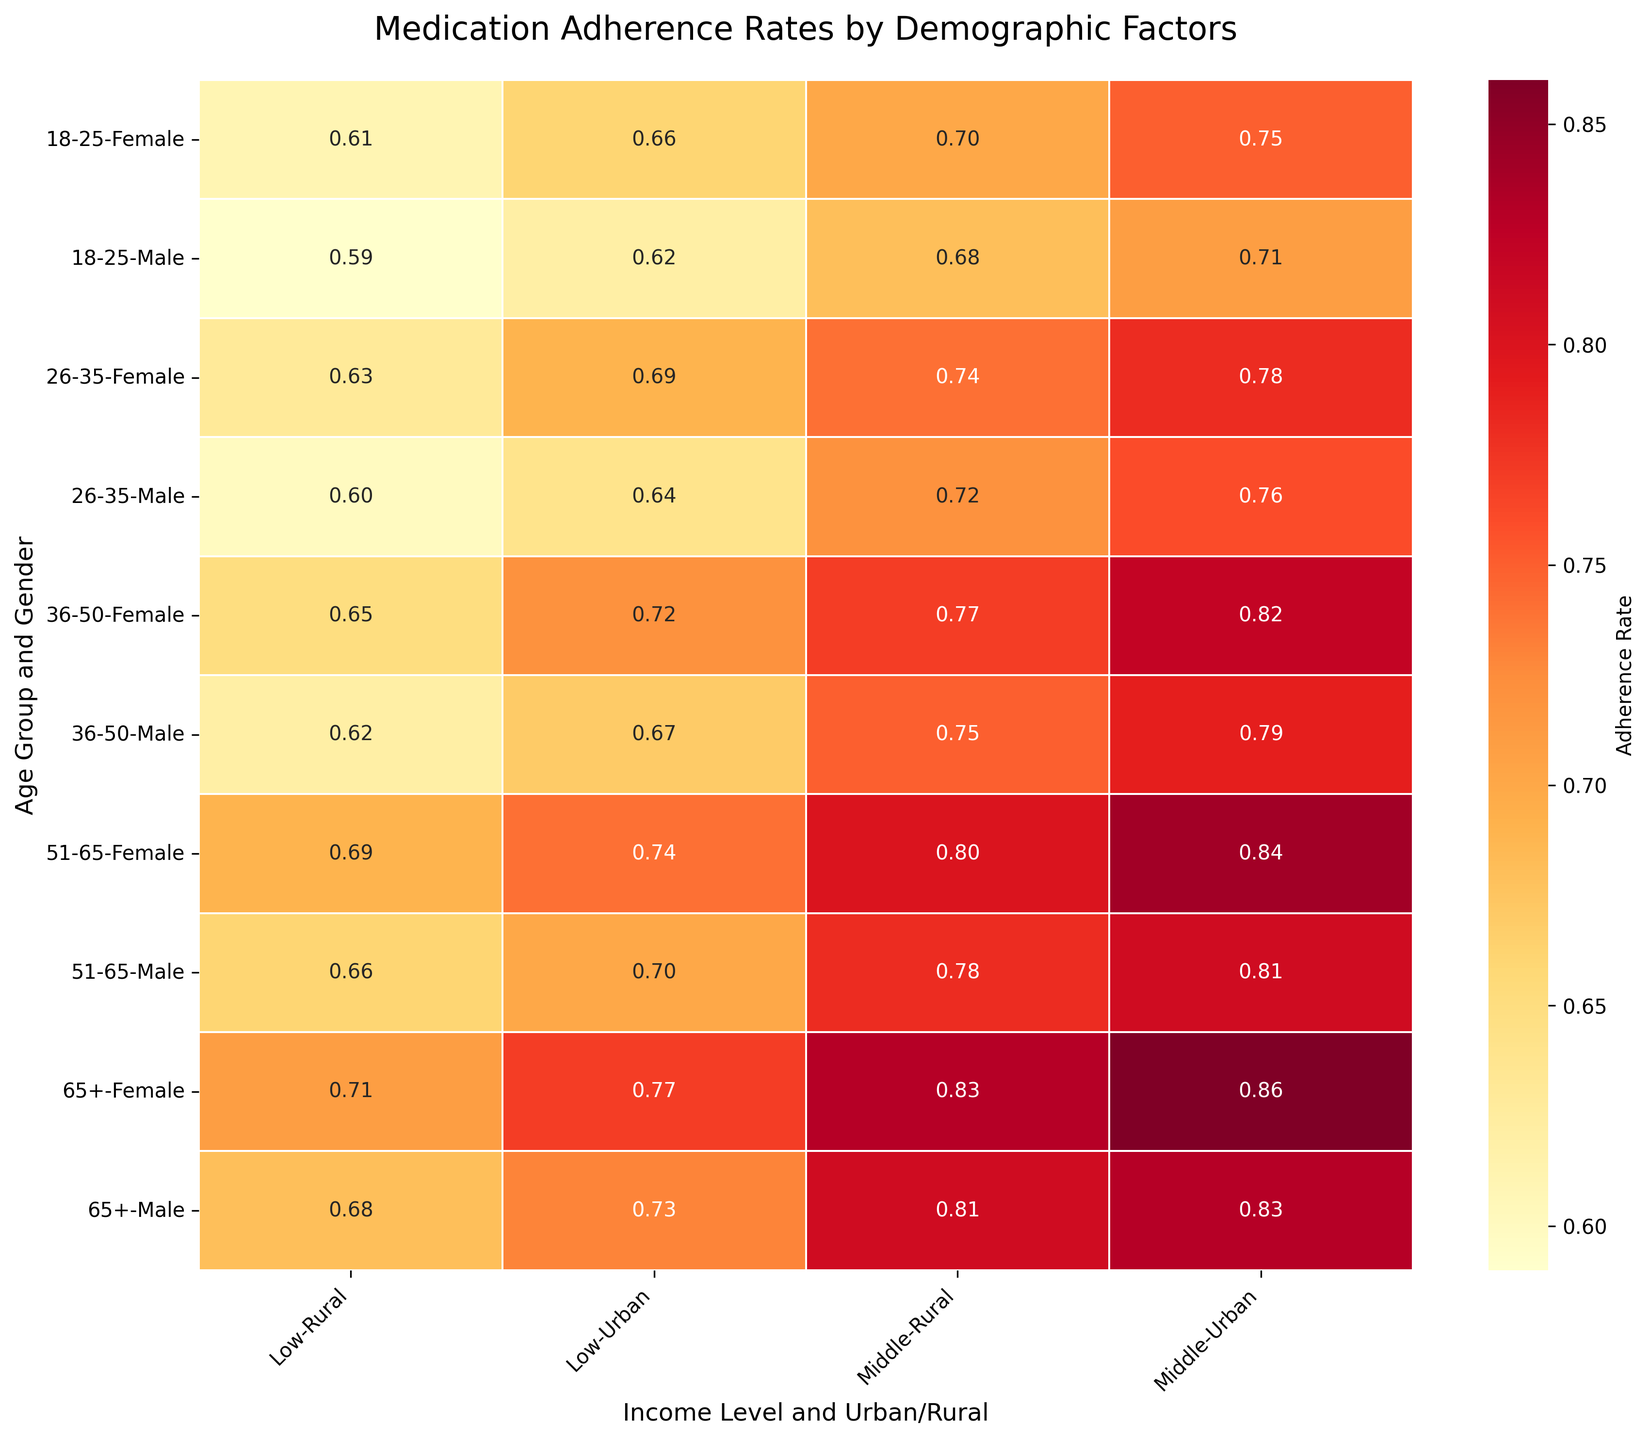What is the title of the heatmap? The title of the heatmap is displayed at the top of the figure.
Answer: Medication Adherence Rates by Demographic Factors Which demographic group has the highest adherence rate? The highest adherence rate is indicated by the darkest shade on the heatmap. This corresponds to the "65+, Middle Income, Female, Urban" group.
Answer: 0.86 How does the adherence rate for females compare between urban and rural settings for the age group 51-65 and middle income? By examining the heatmap, we can see the adherence rates for females aged 51-65 in the middle-income bracket are higher in urban settings compared to rural settings.
Answer: Urban: 0.84, Rural: 0.80 Is there a general trend in adherence rates between income levels for the age group 36-50? By comparing the colors for low and middle-income levels for each gender in this age group, we can observe that adherence rates are generally higher for middle-income individuals.
Answer: Middle > Low What is the difference in adherence rates between males and females in the age group 18-25 with middle income in rural settings? Checking the values directly from the heatmap shows that the adherence rate for females is higher by 0.02.
Answer: 0.02 What's the average adherence rate for the group 26-35, low income, urban? The adherence rates for males and females are provided separately. We need to average these two values (0.64 + 0.69)/2 = 0.665.
Answer: 0.665 Which age group shows the least variation in adherence rates across different settings? By visually inspecting the colors and variation in the heatmap, the age group that shows the least variation is 51-65.
Answer: 51-65 For the age group 36-50, how does the adherence rate for urban middle-income males compare to rural low-income females? By looking at the respective values in the heatmap, we see urban middle-income males have an adherence rate of 0.79 while rural low-income females have a rate of 0.65.
Answer: Higher Which gender has a generally higher adherence rate across all income levels and settings for the age group 65+? By examining the colors across the heatmap for the age group 65+, we see that females generally have higher adherence rates.
Answer: Female In terms of adherence rates, how does the urban middle-income setting compare across all age groups for males? By comparing the shades for urban middle-income males across all age groups, we see consistency in high adherence rates across these settings.
Answer: Consistently high 